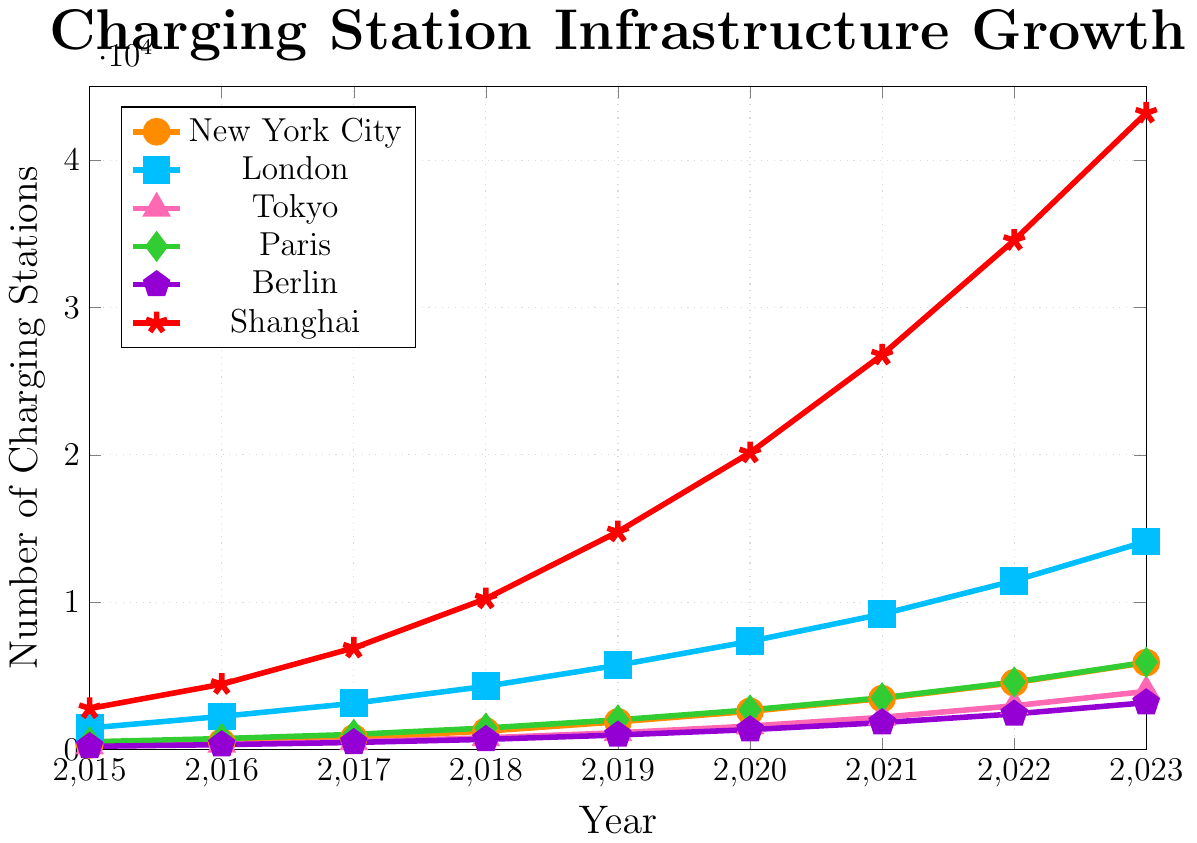What is the total number of charging stations in New York City and Paris in the year 2020? To find the total number of charging stations in New York City and Paris in 2020, add the values for both cities in that specific year. For New York City in 2020, the value is 2589, and for Paris in 2020, it is 2687. Therefore, the total is 2589 + 2687 = 5276.
Answer: 5276 Which city experienced the highest growth in the number of charging stations from 2015 to 2023? To determine the highest growth, calculate the difference in the number of charging stations from 2015 to 2023 for each city and compare them. For New York City, the growth is 5897 - 312 = 5585. For London, it's 14123 - 1458 = 12665. For Tokyo, it's 3945 - 231 = 3714. For Paris, it's 5923 - 522 = 5401. For Berlin, it's 3178 - 213 = 2965. For Shanghai, it's 43210 - 2783 = 40427. Shanghai experienced the highest growth.
Answer: Shanghai In 2019, which city had the second highest number of charging stations after Shanghai? To find the second highest number of charging stations in 2019, look at the values for each city. Shanghai had the highest number with 14782. Comparing the other cities, New York City had 1876, London had 5721, Tokyo had 1134, Paris had 2013, and Berlin had 982. The second highest is London with 5721.
Answer: London What was the average number of charging stations in Berlin from 2015 to 2023? To find the average, sum up the number of charging stations in Berlin for the given years and then divide by the number of years. The sum is 213 + 328 + 476 + 687 + 982 + 1346 + 1823 + 2412 + 3178 = 11445. There are 9 years, so the average is 11445/9 = 1271.67.
Answer: 1271.67 By how much did the number of charging stations in Tokyo increase from 2017 to 2020? To find the increase, subtract the number of stations in Tokyo in 2017 from the number in 2020. The value in 2017 is 528, and in 2020 it is 1587. Therefore, the increase is 1587 - 528 = 1059.
Answer: 1059 Which city had the least number of charging stations in 2018, and how many were there? To determine the city with the least number of charging stations in 2018, compare the values for each city. New York City had 1245, London had 4289, Tokyo had 793, Paris had 1458, Berlin had 687, and Shanghai had 10236. Berlin had the least with 687 charging stations.
Answer: Berlin, 687 What is the ratio of the number of charging stations in London to those in Paris in 2023? To find the ratio, divide the number of charging stations in London by those in Paris in 2023. London had 14123, and Paris had 5923. The ratio is 14123/5923, which simplifies to approximately 2.38.
Answer: 2.38 How many more charging stations did Shanghai have compared to the combined total of New York City and Tokyo in 2022? First, find the combined total of New York City and Tokyo in 2022: 4532 + 2967 = 7499. Next, subtract this total from the number of stations in Shanghai in 2022. Shanghai had 34567 in 2022, so 34567 - 7499 = 27068.
Answer: 27068 